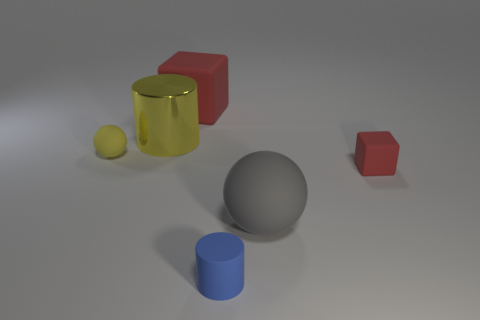Add 2 small red things. How many objects exist? 8 Subtract all cylinders. How many objects are left? 4 Subtract all yellow spheres. Subtract all tiny rubber things. How many objects are left? 2 Add 1 small spheres. How many small spheres are left? 2 Add 1 small blue blocks. How many small blue blocks exist? 1 Subtract 0 gray cylinders. How many objects are left? 6 